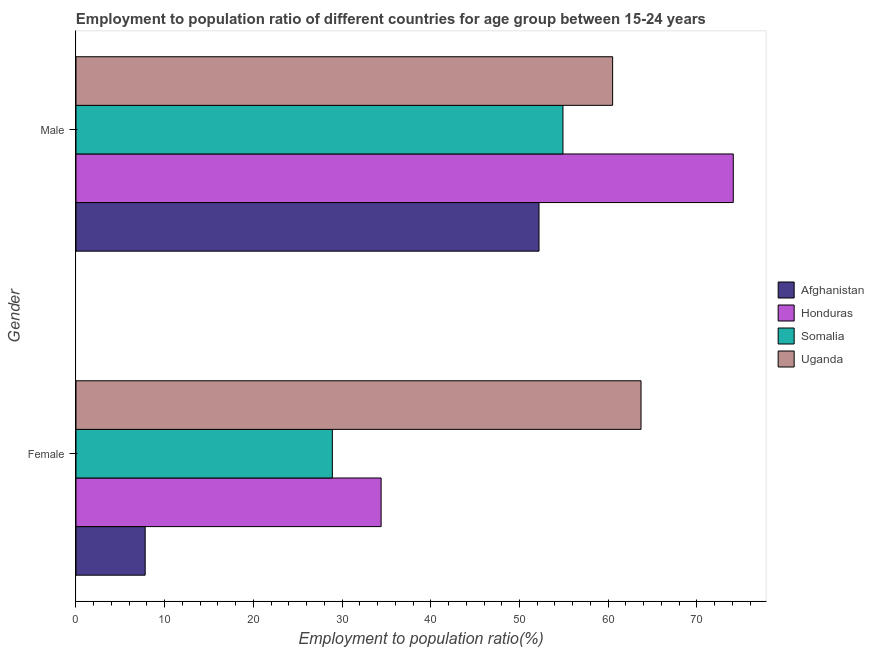How many groups of bars are there?
Provide a succinct answer. 2. Are the number of bars on each tick of the Y-axis equal?
Keep it short and to the point. Yes. What is the label of the 2nd group of bars from the top?
Provide a succinct answer. Female. What is the employment to population ratio(female) in Uganda?
Make the answer very short. 63.7. Across all countries, what is the maximum employment to population ratio(female)?
Offer a terse response. 63.7. Across all countries, what is the minimum employment to population ratio(male)?
Provide a succinct answer. 52.2. In which country was the employment to population ratio(male) maximum?
Give a very brief answer. Honduras. In which country was the employment to population ratio(male) minimum?
Offer a very short reply. Afghanistan. What is the total employment to population ratio(male) in the graph?
Your response must be concise. 241.7. What is the difference between the employment to population ratio(male) in Uganda and that in Somalia?
Keep it short and to the point. 5.6. What is the difference between the employment to population ratio(male) in Uganda and the employment to population ratio(female) in Honduras?
Your answer should be very brief. 26.1. What is the average employment to population ratio(female) per country?
Provide a short and direct response. 33.7. What is the difference between the employment to population ratio(male) and employment to population ratio(female) in Uganda?
Make the answer very short. -3.2. In how many countries, is the employment to population ratio(female) greater than 8 %?
Offer a terse response. 3. What is the ratio of the employment to population ratio(female) in Honduras to that in Uganda?
Keep it short and to the point. 0.54. Is the employment to population ratio(male) in Honduras less than that in Somalia?
Provide a short and direct response. No. What does the 2nd bar from the top in Male represents?
Your response must be concise. Somalia. What does the 2nd bar from the bottom in Female represents?
Your answer should be compact. Honduras. How many bars are there?
Offer a terse response. 8. Are all the bars in the graph horizontal?
Ensure brevity in your answer.  Yes. What is the difference between two consecutive major ticks on the X-axis?
Your answer should be very brief. 10. Are the values on the major ticks of X-axis written in scientific E-notation?
Give a very brief answer. No. Does the graph contain any zero values?
Your response must be concise. No. Where does the legend appear in the graph?
Provide a short and direct response. Center right. What is the title of the graph?
Your response must be concise. Employment to population ratio of different countries for age group between 15-24 years. Does "Comoros" appear as one of the legend labels in the graph?
Give a very brief answer. No. What is the label or title of the Y-axis?
Your answer should be compact. Gender. What is the Employment to population ratio(%) of Afghanistan in Female?
Provide a short and direct response. 7.8. What is the Employment to population ratio(%) of Honduras in Female?
Your answer should be compact. 34.4. What is the Employment to population ratio(%) of Somalia in Female?
Offer a terse response. 28.9. What is the Employment to population ratio(%) in Uganda in Female?
Offer a very short reply. 63.7. What is the Employment to population ratio(%) in Afghanistan in Male?
Your response must be concise. 52.2. What is the Employment to population ratio(%) of Honduras in Male?
Ensure brevity in your answer.  74.1. What is the Employment to population ratio(%) of Somalia in Male?
Keep it short and to the point. 54.9. What is the Employment to population ratio(%) of Uganda in Male?
Your response must be concise. 60.5. Across all Gender, what is the maximum Employment to population ratio(%) in Afghanistan?
Provide a succinct answer. 52.2. Across all Gender, what is the maximum Employment to population ratio(%) in Honduras?
Your answer should be very brief. 74.1. Across all Gender, what is the maximum Employment to population ratio(%) in Somalia?
Keep it short and to the point. 54.9. Across all Gender, what is the maximum Employment to population ratio(%) of Uganda?
Make the answer very short. 63.7. Across all Gender, what is the minimum Employment to population ratio(%) of Afghanistan?
Provide a short and direct response. 7.8. Across all Gender, what is the minimum Employment to population ratio(%) in Honduras?
Your answer should be compact. 34.4. Across all Gender, what is the minimum Employment to population ratio(%) of Somalia?
Your response must be concise. 28.9. Across all Gender, what is the minimum Employment to population ratio(%) of Uganda?
Provide a succinct answer. 60.5. What is the total Employment to population ratio(%) in Afghanistan in the graph?
Provide a short and direct response. 60. What is the total Employment to population ratio(%) in Honduras in the graph?
Offer a terse response. 108.5. What is the total Employment to population ratio(%) of Somalia in the graph?
Ensure brevity in your answer.  83.8. What is the total Employment to population ratio(%) of Uganda in the graph?
Provide a succinct answer. 124.2. What is the difference between the Employment to population ratio(%) of Afghanistan in Female and that in Male?
Your answer should be compact. -44.4. What is the difference between the Employment to population ratio(%) in Honduras in Female and that in Male?
Ensure brevity in your answer.  -39.7. What is the difference between the Employment to population ratio(%) of Uganda in Female and that in Male?
Offer a terse response. 3.2. What is the difference between the Employment to population ratio(%) of Afghanistan in Female and the Employment to population ratio(%) of Honduras in Male?
Your answer should be compact. -66.3. What is the difference between the Employment to population ratio(%) of Afghanistan in Female and the Employment to population ratio(%) of Somalia in Male?
Offer a very short reply. -47.1. What is the difference between the Employment to population ratio(%) of Afghanistan in Female and the Employment to population ratio(%) of Uganda in Male?
Offer a terse response. -52.7. What is the difference between the Employment to population ratio(%) of Honduras in Female and the Employment to population ratio(%) of Somalia in Male?
Offer a very short reply. -20.5. What is the difference between the Employment to population ratio(%) of Honduras in Female and the Employment to population ratio(%) of Uganda in Male?
Provide a short and direct response. -26.1. What is the difference between the Employment to population ratio(%) of Somalia in Female and the Employment to population ratio(%) of Uganda in Male?
Provide a short and direct response. -31.6. What is the average Employment to population ratio(%) of Afghanistan per Gender?
Ensure brevity in your answer.  30. What is the average Employment to population ratio(%) of Honduras per Gender?
Make the answer very short. 54.25. What is the average Employment to population ratio(%) in Somalia per Gender?
Your response must be concise. 41.9. What is the average Employment to population ratio(%) in Uganda per Gender?
Offer a terse response. 62.1. What is the difference between the Employment to population ratio(%) in Afghanistan and Employment to population ratio(%) in Honduras in Female?
Give a very brief answer. -26.6. What is the difference between the Employment to population ratio(%) of Afghanistan and Employment to population ratio(%) of Somalia in Female?
Offer a terse response. -21.1. What is the difference between the Employment to population ratio(%) in Afghanistan and Employment to population ratio(%) in Uganda in Female?
Make the answer very short. -55.9. What is the difference between the Employment to population ratio(%) of Honduras and Employment to population ratio(%) of Somalia in Female?
Offer a very short reply. 5.5. What is the difference between the Employment to population ratio(%) in Honduras and Employment to population ratio(%) in Uganda in Female?
Offer a very short reply. -29.3. What is the difference between the Employment to population ratio(%) in Somalia and Employment to population ratio(%) in Uganda in Female?
Give a very brief answer. -34.8. What is the difference between the Employment to population ratio(%) in Afghanistan and Employment to population ratio(%) in Honduras in Male?
Your answer should be compact. -21.9. What is the difference between the Employment to population ratio(%) of Afghanistan and Employment to population ratio(%) of Uganda in Male?
Your answer should be very brief. -8.3. What is the difference between the Employment to population ratio(%) in Honduras and Employment to population ratio(%) in Somalia in Male?
Your response must be concise. 19.2. What is the difference between the Employment to population ratio(%) of Honduras and Employment to population ratio(%) of Uganda in Male?
Provide a succinct answer. 13.6. What is the difference between the Employment to population ratio(%) in Somalia and Employment to population ratio(%) in Uganda in Male?
Ensure brevity in your answer.  -5.6. What is the ratio of the Employment to population ratio(%) in Afghanistan in Female to that in Male?
Make the answer very short. 0.15. What is the ratio of the Employment to population ratio(%) in Honduras in Female to that in Male?
Provide a succinct answer. 0.46. What is the ratio of the Employment to population ratio(%) in Somalia in Female to that in Male?
Your answer should be very brief. 0.53. What is the ratio of the Employment to population ratio(%) in Uganda in Female to that in Male?
Provide a short and direct response. 1.05. What is the difference between the highest and the second highest Employment to population ratio(%) of Afghanistan?
Your response must be concise. 44.4. What is the difference between the highest and the second highest Employment to population ratio(%) in Honduras?
Your answer should be compact. 39.7. What is the difference between the highest and the second highest Employment to population ratio(%) in Somalia?
Your answer should be very brief. 26. What is the difference between the highest and the lowest Employment to population ratio(%) of Afghanistan?
Give a very brief answer. 44.4. What is the difference between the highest and the lowest Employment to population ratio(%) of Honduras?
Make the answer very short. 39.7. What is the difference between the highest and the lowest Employment to population ratio(%) of Somalia?
Your answer should be very brief. 26. 